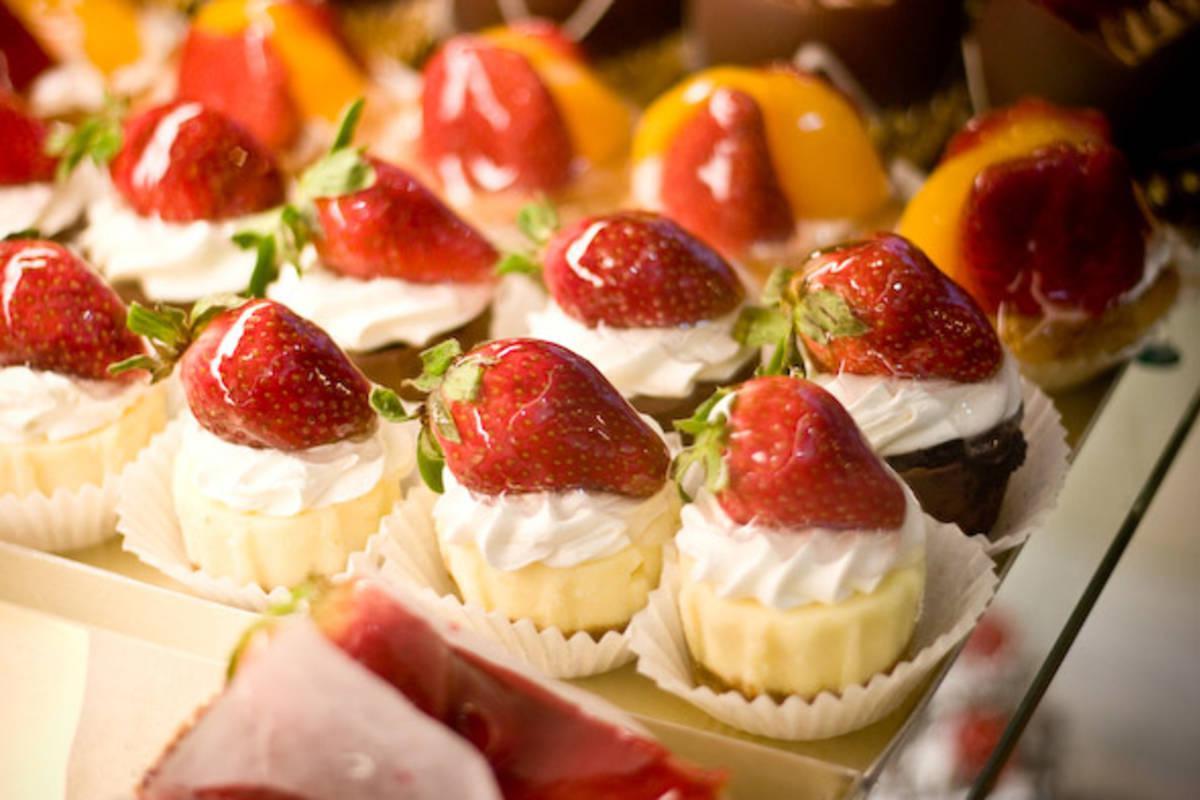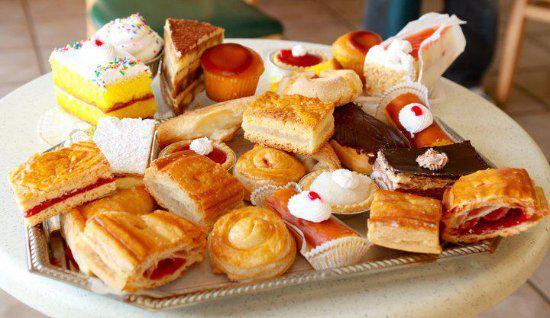The first image is the image on the left, the second image is the image on the right. Evaluate the accuracy of this statement regarding the images: "There are strawberries on top of some of the desserts.". Is it true? Answer yes or no. Yes. The first image is the image on the left, the second image is the image on the right. Considering the images on both sides, is "The left image shows individual round desserts in rows on a tray, and at least one row of desserts have red berries on top." valid? Answer yes or no. Yes. 